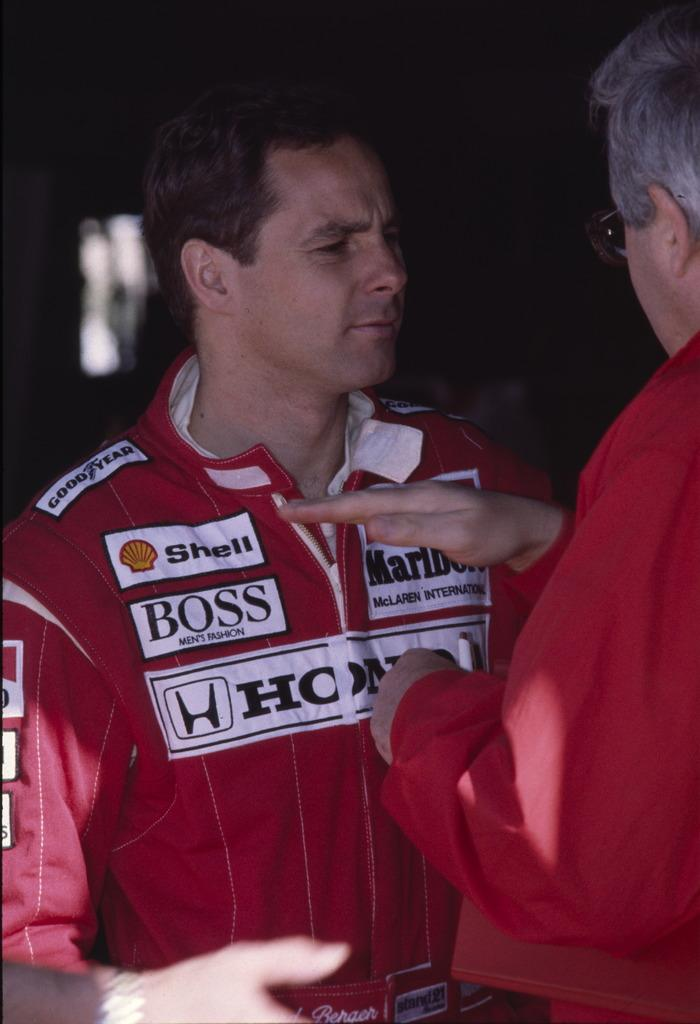<image>
Present a compact description of the photo's key features. An older man speaks to a younger man in a red coverall suit with a Shell patch. 